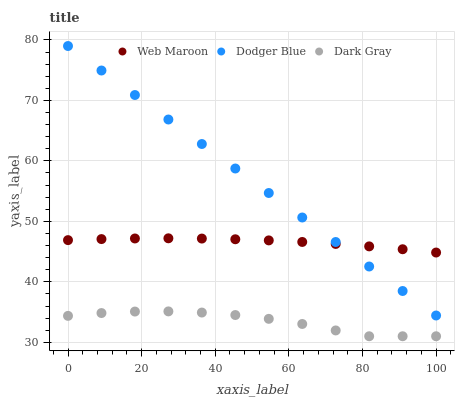Does Dark Gray have the minimum area under the curve?
Answer yes or no. Yes. Does Dodger Blue have the maximum area under the curve?
Answer yes or no. Yes. Does Web Maroon have the minimum area under the curve?
Answer yes or no. No. Does Web Maroon have the maximum area under the curve?
Answer yes or no. No. Is Dodger Blue the smoothest?
Answer yes or no. Yes. Is Dark Gray the roughest?
Answer yes or no. Yes. Is Web Maroon the smoothest?
Answer yes or no. No. Is Web Maroon the roughest?
Answer yes or no. No. Does Dark Gray have the lowest value?
Answer yes or no. Yes. Does Dodger Blue have the lowest value?
Answer yes or no. No. Does Dodger Blue have the highest value?
Answer yes or no. Yes. Does Web Maroon have the highest value?
Answer yes or no. No. Is Dark Gray less than Dodger Blue?
Answer yes or no. Yes. Is Web Maroon greater than Dark Gray?
Answer yes or no. Yes. Does Dodger Blue intersect Web Maroon?
Answer yes or no. Yes. Is Dodger Blue less than Web Maroon?
Answer yes or no. No. Is Dodger Blue greater than Web Maroon?
Answer yes or no. No. Does Dark Gray intersect Dodger Blue?
Answer yes or no. No. 